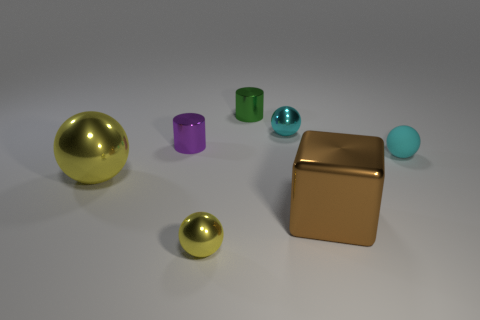How many things are either tiny cylinders that are in front of the green metallic thing or small metal objects behind the big block?
Provide a short and direct response. 3. How many things are either cyan things or things that are on the right side of the large yellow shiny thing?
Your answer should be very brief. 6. There is a metal thing that is to the right of the shiny sphere that is to the right of the yellow shiny sphere to the right of the small purple metal object; what size is it?
Ensure brevity in your answer.  Large. What is the material of the other object that is the same size as the brown metallic object?
Your answer should be compact. Metal. Is there a brown metal thing of the same size as the green thing?
Offer a terse response. No. There is a cyan ball that is to the right of the brown block; does it have the same size as the large brown metal block?
Offer a very short reply. No. The object that is right of the small green metal object and behind the cyan matte thing has what shape?
Ensure brevity in your answer.  Sphere. Are there more yellow metallic things in front of the big brown shiny thing than brown rubber cubes?
Make the answer very short. Yes. The brown cube that is made of the same material as the green cylinder is what size?
Give a very brief answer. Large. What number of tiny things are the same color as the large ball?
Your response must be concise. 1. 